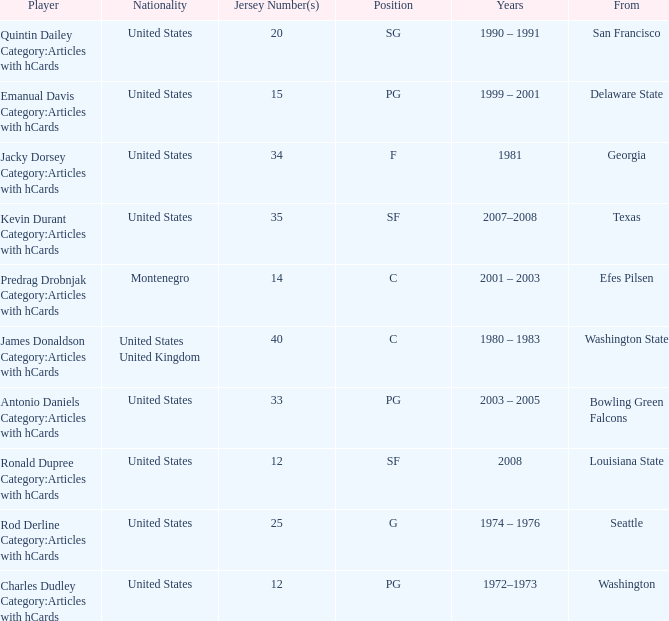What is the lowest jersey number of a player from louisiana state? 12.0. 